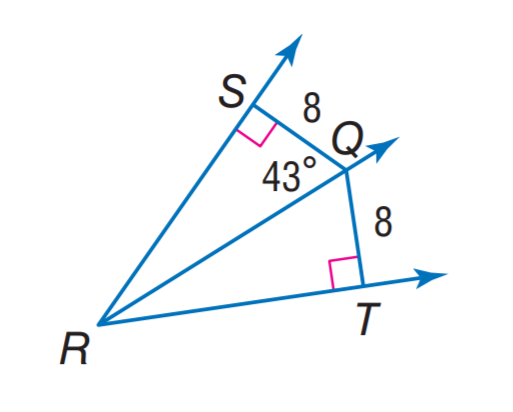Answer the mathemtical geometry problem and directly provide the correct option letter.
Question: Find m \angle T Q R.
Choices: A: 8 B: 34 C: 43 D: 44 C 